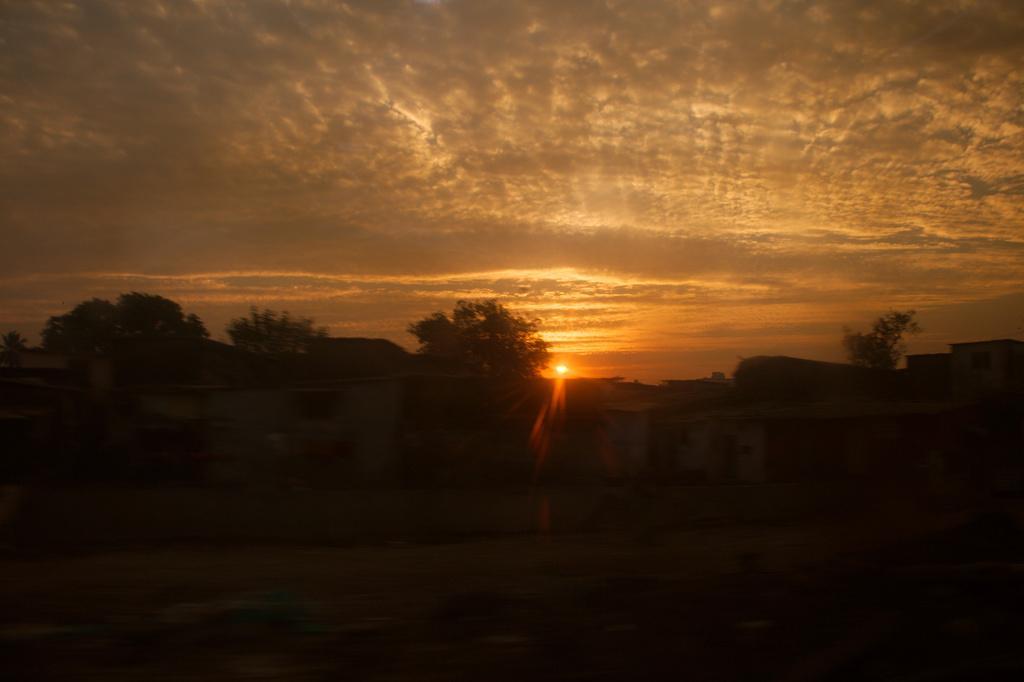Could you give a brief overview of what you see in this image? In this image, we can see trees, sheds, and there is sunset. 